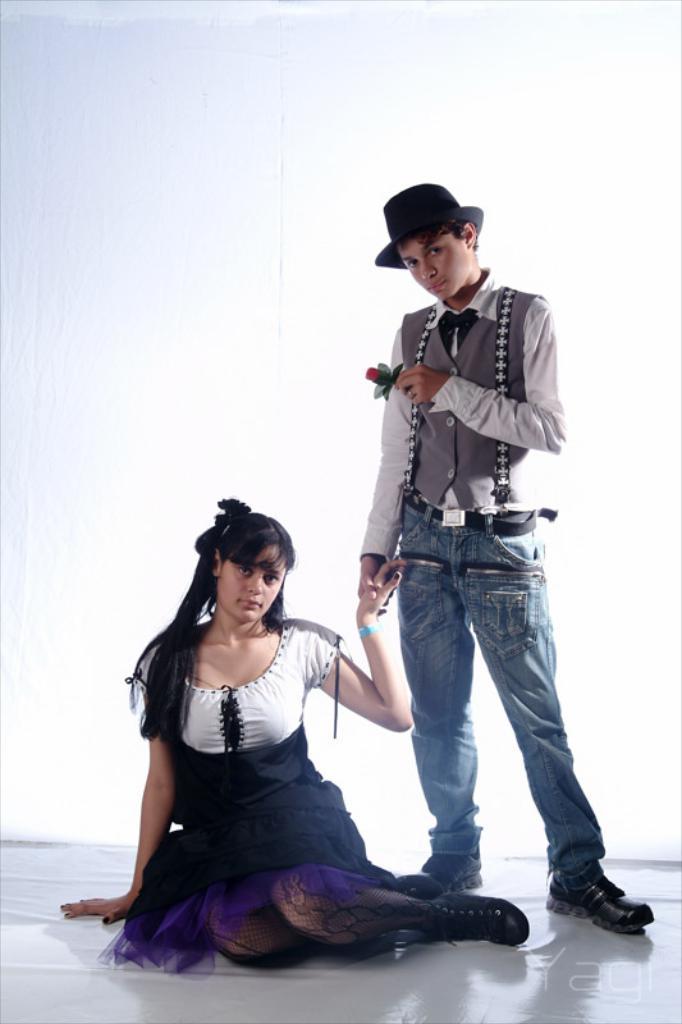Could you give a brief overview of what you see in this image? In the image there is a boy and a girl, the girl is sitting on the floor and the boy is holding the hand of a girl and in the other hand he is also holding a rose flower,the background of these two people is white color. 